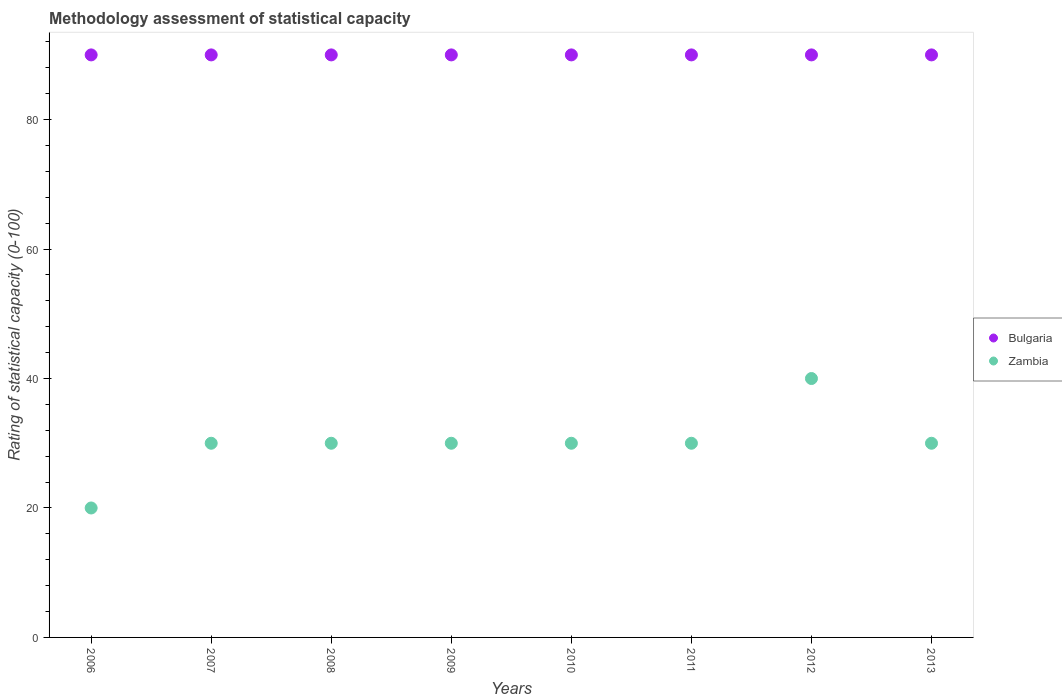Is the number of dotlines equal to the number of legend labels?
Offer a very short reply. Yes. What is the rating of statistical capacity in Zambia in 2012?
Offer a very short reply. 40. Across all years, what is the maximum rating of statistical capacity in Bulgaria?
Your answer should be very brief. 90. Across all years, what is the minimum rating of statistical capacity in Zambia?
Your response must be concise. 20. In which year was the rating of statistical capacity in Zambia maximum?
Ensure brevity in your answer.  2012. In which year was the rating of statistical capacity in Zambia minimum?
Offer a terse response. 2006. What is the total rating of statistical capacity in Bulgaria in the graph?
Ensure brevity in your answer.  720. What is the difference between the rating of statistical capacity in Zambia in 2012 and the rating of statistical capacity in Bulgaria in 2009?
Offer a terse response. -50. What is the average rating of statistical capacity in Bulgaria per year?
Give a very brief answer. 90. In the year 2009, what is the difference between the rating of statistical capacity in Bulgaria and rating of statistical capacity in Zambia?
Your answer should be compact. 60. In how many years, is the rating of statistical capacity in Zambia greater than 20?
Give a very brief answer. 7. What is the difference between the highest and the second highest rating of statistical capacity in Zambia?
Your response must be concise. 10. Does the rating of statistical capacity in Bulgaria monotonically increase over the years?
Keep it short and to the point. No. How many dotlines are there?
Provide a succinct answer. 2. What is the difference between two consecutive major ticks on the Y-axis?
Your response must be concise. 20. Are the values on the major ticks of Y-axis written in scientific E-notation?
Provide a short and direct response. No. Does the graph contain grids?
Ensure brevity in your answer.  No. What is the title of the graph?
Give a very brief answer. Methodology assessment of statistical capacity. What is the label or title of the X-axis?
Provide a short and direct response. Years. What is the label or title of the Y-axis?
Offer a terse response. Rating of statistical capacity (0-100). What is the Rating of statistical capacity (0-100) of Bulgaria in 2006?
Keep it short and to the point. 90. What is the Rating of statistical capacity (0-100) of Zambia in 2006?
Give a very brief answer. 20. What is the Rating of statistical capacity (0-100) of Zambia in 2007?
Provide a short and direct response. 30. What is the Rating of statistical capacity (0-100) of Zambia in 2008?
Offer a very short reply. 30. What is the Rating of statistical capacity (0-100) of Bulgaria in 2009?
Make the answer very short. 90. What is the Rating of statistical capacity (0-100) of Bulgaria in 2010?
Make the answer very short. 90. What is the Rating of statistical capacity (0-100) of Bulgaria in 2011?
Provide a short and direct response. 90. What is the Rating of statistical capacity (0-100) in Zambia in 2011?
Your answer should be very brief. 30. What is the Rating of statistical capacity (0-100) of Bulgaria in 2012?
Make the answer very short. 90. What is the Rating of statistical capacity (0-100) of Zambia in 2012?
Ensure brevity in your answer.  40. What is the Rating of statistical capacity (0-100) of Bulgaria in 2013?
Your answer should be compact. 90. Across all years, what is the maximum Rating of statistical capacity (0-100) of Bulgaria?
Provide a short and direct response. 90. Across all years, what is the maximum Rating of statistical capacity (0-100) in Zambia?
Provide a short and direct response. 40. Across all years, what is the minimum Rating of statistical capacity (0-100) in Zambia?
Offer a very short reply. 20. What is the total Rating of statistical capacity (0-100) of Bulgaria in the graph?
Provide a succinct answer. 720. What is the total Rating of statistical capacity (0-100) of Zambia in the graph?
Keep it short and to the point. 240. What is the difference between the Rating of statistical capacity (0-100) of Bulgaria in 2006 and that in 2008?
Make the answer very short. 0. What is the difference between the Rating of statistical capacity (0-100) of Bulgaria in 2006 and that in 2009?
Give a very brief answer. 0. What is the difference between the Rating of statistical capacity (0-100) of Bulgaria in 2006 and that in 2010?
Ensure brevity in your answer.  0. What is the difference between the Rating of statistical capacity (0-100) of Zambia in 2006 and that in 2010?
Make the answer very short. -10. What is the difference between the Rating of statistical capacity (0-100) in Zambia in 2006 and that in 2011?
Ensure brevity in your answer.  -10. What is the difference between the Rating of statistical capacity (0-100) in Zambia in 2007 and that in 2008?
Provide a succinct answer. 0. What is the difference between the Rating of statistical capacity (0-100) in Bulgaria in 2007 and that in 2009?
Keep it short and to the point. 0. What is the difference between the Rating of statistical capacity (0-100) in Zambia in 2007 and that in 2011?
Make the answer very short. 0. What is the difference between the Rating of statistical capacity (0-100) in Bulgaria in 2007 and that in 2012?
Offer a terse response. 0. What is the difference between the Rating of statistical capacity (0-100) in Zambia in 2007 and that in 2012?
Your answer should be very brief. -10. What is the difference between the Rating of statistical capacity (0-100) in Bulgaria in 2007 and that in 2013?
Offer a terse response. 0. What is the difference between the Rating of statistical capacity (0-100) in Zambia in 2007 and that in 2013?
Keep it short and to the point. 0. What is the difference between the Rating of statistical capacity (0-100) in Bulgaria in 2008 and that in 2010?
Offer a terse response. 0. What is the difference between the Rating of statistical capacity (0-100) of Bulgaria in 2008 and that in 2011?
Provide a succinct answer. 0. What is the difference between the Rating of statistical capacity (0-100) of Zambia in 2008 and that in 2011?
Your answer should be compact. 0. What is the difference between the Rating of statistical capacity (0-100) of Bulgaria in 2008 and that in 2013?
Provide a short and direct response. 0. What is the difference between the Rating of statistical capacity (0-100) in Bulgaria in 2009 and that in 2010?
Ensure brevity in your answer.  0. What is the difference between the Rating of statistical capacity (0-100) of Bulgaria in 2009 and that in 2011?
Make the answer very short. 0. What is the difference between the Rating of statistical capacity (0-100) of Zambia in 2009 and that in 2012?
Keep it short and to the point. -10. What is the difference between the Rating of statistical capacity (0-100) of Bulgaria in 2009 and that in 2013?
Your answer should be compact. 0. What is the difference between the Rating of statistical capacity (0-100) of Zambia in 2009 and that in 2013?
Your answer should be compact. 0. What is the difference between the Rating of statistical capacity (0-100) of Bulgaria in 2010 and that in 2011?
Provide a succinct answer. 0. What is the difference between the Rating of statistical capacity (0-100) of Zambia in 2010 and that in 2011?
Give a very brief answer. 0. What is the difference between the Rating of statistical capacity (0-100) of Zambia in 2010 and that in 2012?
Ensure brevity in your answer.  -10. What is the difference between the Rating of statistical capacity (0-100) in Zambia in 2010 and that in 2013?
Provide a succinct answer. 0. What is the difference between the Rating of statistical capacity (0-100) in Bulgaria in 2011 and that in 2012?
Provide a succinct answer. 0. What is the difference between the Rating of statistical capacity (0-100) in Zambia in 2011 and that in 2012?
Provide a succinct answer. -10. What is the difference between the Rating of statistical capacity (0-100) of Bulgaria in 2011 and that in 2013?
Your answer should be compact. 0. What is the difference between the Rating of statistical capacity (0-100) in Zambia in 2012 and that in 2013?
Keep it short and to the point. 10. What is the difference between the Rating of statistical capacity (0-100) of Bulgaria in 2006 and the Rating of statistical capacity (0-100) of Zambia in 2008?
Ensure brevity in your answer.  60. What is the difference between the Rating of statistical capacity (0-100) in Bulgaria in 2006 and the Rating of statistical capacity (0-100) in Zambia in 2009?
Make the answer very short. 60. What is the difference between the Rating of statistical capacity (0-100) of Bulgaria in 2006 and the Rating of statistical capacity (0-100) of Zambia in 2010?
Offer a terse response. 60. What is the difference between the Rating of statistical capacity (0-100) of Bulgaria in 2007 and the Rating of statistical capacity (0-100) of Zambia in 2008?
Ensure brevity in your answer.  60. What is the difference between the Rating of statistical capacity (0-100) in Bulgaria in 2007 and the Rating of statistical capacity (0-100) in Zambia in 2010?
Offer a very short reply. 60. What is the difference between the Rating of statistical capacity (0-100) of Bulgaria in 2007 and the Rating of statistical capacity (0-100) of Zambia in 2011?
Keep it short and to the point. 60. What is the difference between the Rating of statistical capacity (0-100) in Bulgaria in 2007 and the Rating of statistical capacity (0-100) in Zambia in 2012?
Provide a short and direct response. 50. What is the difference between the Rating of statistical capacity (0-100) in Bulgaria in 2007 and the Rating of statistical capacity (0-100) in Zambia in 2013?
Keep it short and to the point. 60. What is the difference between the Rating of statistical capacity (0-100) of Bulgaria in 2008 and the Rating of statistical capacity (0-100) of Zambia in 2010?
Your answer should be very brief. 60. What is the difference between the Rating of statistical capacity (0-100) of Bulgaria in 2009 and the Rating of statistical capacity (0-100) of Zambia in 2011?
Provide a succinct answer. 60. What is the difference between the Rating of statistical capacity (0-100) of Bulgaria in 2009 and the Rating of statistical capacity (0-100) of Zambia in 2012?
Give a very brief answer. 50. What is the difference between the Rating of statistical capacity (0-100) of Bulgaria in 2010 and the Rating of statistical capacity (0-100) of Zambia in 2012?
Provide a succinct answer. 50. What is the difference between the Rating of statistical capacity (0-100) in Bulgaria in 2011 and the Rating of statistical capacity (0-100) in Zambia in 2012?
Offer a terse response. 50. What is the difference between the Rating of statistical capacity (0-100) of Bulgaria in 2011 and the Rating of statistical capacity (0-100) of Zambia in 2013?
Make the answer very short. 60. What is the average Rating of statistical capacity (0-100) in Zambia per year?
Offer a terse response. 30. In the year 2009, what is the difference between the Rating of statistical capacity (0-100) of Bulgaria and Rating of statistical capacity (0-100) of Zambia?
Your response must be concise. 60. In the year 2012, what is the difference between the Rating of statistical capacity (0-100) in Bulgaria and Rating of statistical capacity (0-100) in Zambia?
Provide a short and direct response. 50. What is the ratio of the Rating of statistical capacity (0-100) of Zambia in 2006 to that in 2007?
Keep it short and to the point. 0.67. What is the ratio of the Rating of statistical capacity (0-100) of Bulgaria in 2006 to that in 2010?
Make the answer very short. 1. What is the ratio of the Rating of statistical capacity (0-100) of Bulgaria in 2006 to that in 2011?
Your answer should be very brief. 1. What is the ratio of the Rating of statistical capacity (0-100) in Zambia in 2006 to that in 2011?
Offer a very short reply. 0.67. What is the ratio of the Rating of statistical capacity (0-100) of Bulgaria in 2006 to that in 2012?
Offer a very short reply. 1. What is the ratio of the Rating of statistical capacity (0-100) in Bulgaria in 2006 to that in 2013?
Keep it short and to the point. 1. What is the ratio of the Rating of statistical capacity (0-100) in Zambia in 2006 to that in 2013?
Provide a succinct answer. 0.67. What is the ratio of the Rating of statistical capacity (0-100) in Bulgaria in 2007 to that in 2008?
Offer a very short reply. 1. What is the ratio of the Rating of statistical capacity (0-100) in Zambia in 2007 to that in 2008?
Offer a terse response. 1. What is the ratio of the Rating of statistical capacity (0-100) of Bulgaria in 2007 to that in 2010?
Give a very brief answer. 1. What is the ratio of the Rating of statistical capacity (0-100) of Zambia in 2007 to that in 2010?
Your answer should be compact. 1. What is the ratio of the Rating of statistical capacity (0-100) in Bulgaria in 2007 to that in 2011?
Ensure brevity in your answer.  1. What is the ratio of the Rating of statistical capacity (0-100) of Zambia in 2007 to that in 2011?
Offer a very short reply. 1. What is the ratio of the Rating of statistical capacity (0-100) of Bulgaria in 2007 to that in 2012?
Your response must be concise. 1. What is the ratio of the Rating of statistical capacity (0-100) of Bulgaria in 2007 to that in 2013?
Make the answer very short. 1. What is the ratio of the Rating of statistical capacity (0-100) in Bulgaria in 2008 to that in 2009?
Your answer should be very brief. 1. What is the ratio of the Rating of statistical capacity (0-100) in Zambia in 2008 to that in 2009?
Offer a terse response. 1. What is the ratio of the Rating of statistical capacity (0-100) of Bulgaria in 2008 to that in 2011?
Keep it short and to the point. 1. What is the ratio of the Rating of statistical capacity (0-100) in Zambia in 2008 to that in 2012?
Your answer should be very brief. 0.75. What is the ratio of the Rating of statistical capacity (0-100) of Bulgaria in 2008 to that in 2013?
Ensure brevity in your answer.  1. What is the ratio of the Rating of statistical capacity (0-100) of Zambia in 2008 to that in 2013?
Your answer should be very brief. 1. What is the ratio of the Rating of statistical capacity (0-100) in Zambia in 2009 to that in 2010?
Give a very brief answer. 1. What is the ratio of the Rating of statistical capacity (0-100) of Bulgaria in 2009 to that in 2011?
Offer a terse response. 1. What is the ratio of the Rating of statistical capacity (0-100) of Zambia in 2009 to that in 2012?
Make the answer very short. 0.75. What is the ratio of the Rating of statistical capacity (0-100) of Zambia in 2010 to that in 2012?
Make the answer very short. 0.75. What is the ratio of the Rating of statistical capacity (0-100) in Zambia in 2010 to that in 2013?
Provide a succinct answer. 1. What is the ratio of the Rating of statistical capacity (0-100) in Bulgaria in 2011 to that in 2012?
Provide a succinct answer. 1. What is the ratio of the Rating of statistical capacity (0-100) in Zambia in 2011 to that in 2013?
Keep it short and to the point. 1. What is the ratio of the Rating of statistical capacity (0-100) of Bulgaria in 2012 to that in 2013?
Make the answer very short. 1. What is the ratio of the Rating of statistical capacity (0-100) of Zambia in 2012 to that in 2013?
Your answer should be very brief. 1.33. What is the difference between the highest and the lowest Rating of statistical capacity (0-100) of Zambia?
Provide a succinct answer. 20. 